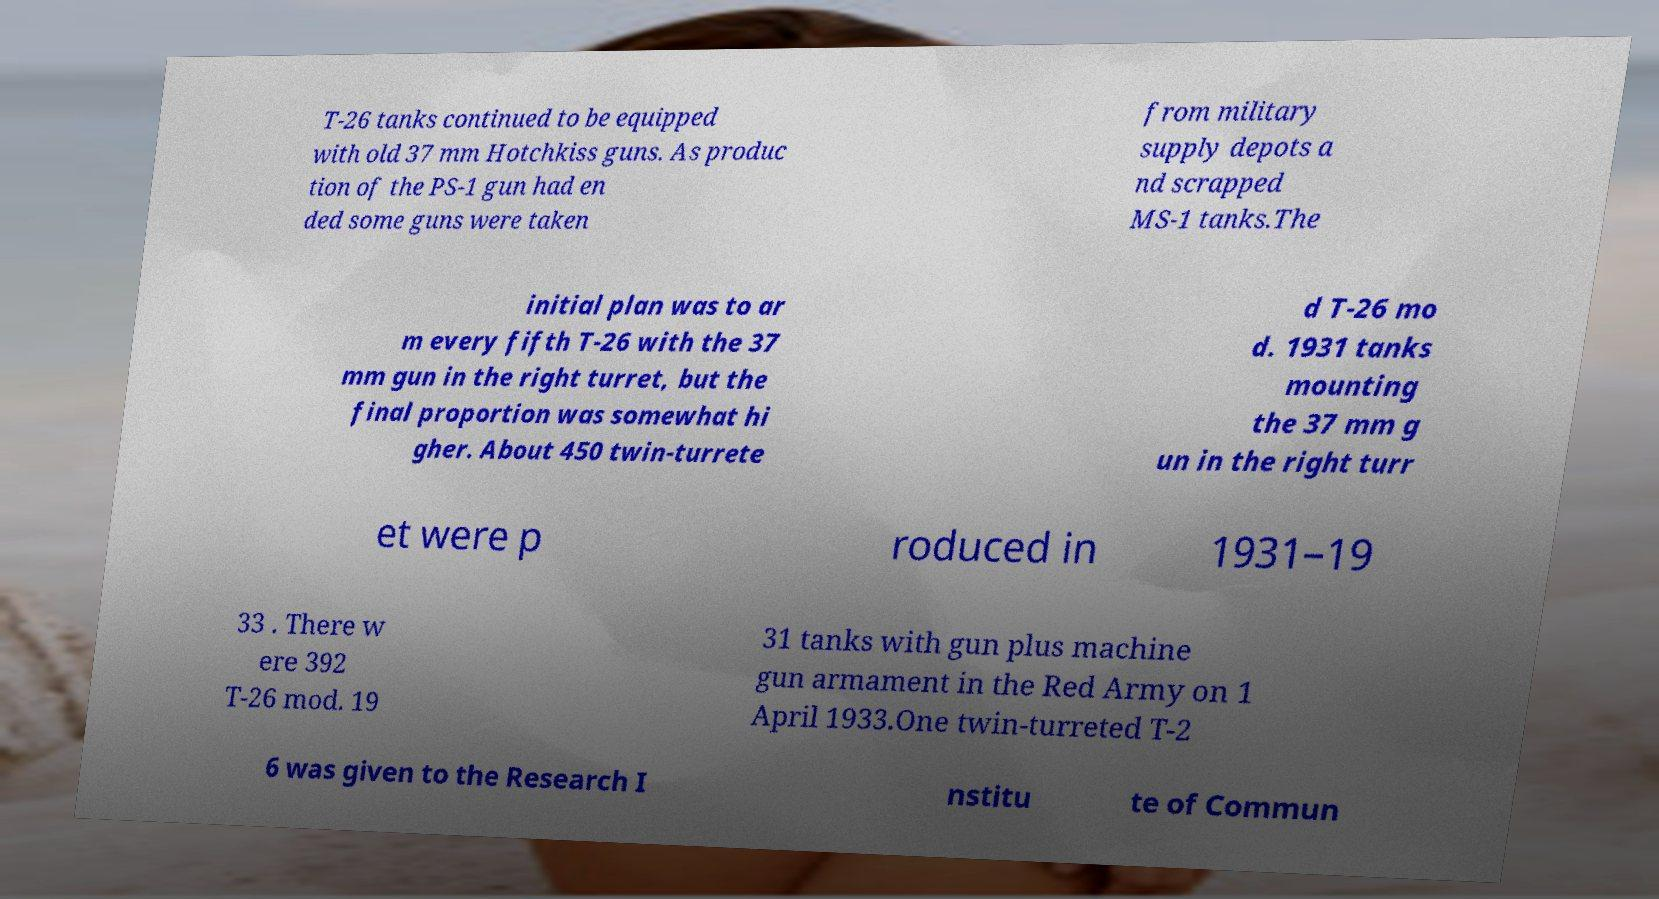Please read and relay the text visible in this image. What does it say? T-26 tanks continued to be equipped with old 37 mm Hotchkiss guns. As produc tion of the PS-1 gun had en ded some guns were taken from military supply depots a nd scrapped MS-1 tanks.The initial plan was to ar m every fifth T-26 with the 37 mm gun in the right turret, but the final proportion was somewhat hi gher. About 450 twin-turrete d T-26 mo d. 1931 tanks mounting the 37 mm g un in the right turr et were p roduced in 1931–19 33 . There w ere 392 T-26 mod. 19 31 tanks with gun plus machine gun armament in the Red Army on 1 April 1933.One twin-turreted T-2 6 was given to the Research I nstitu te of Commun 